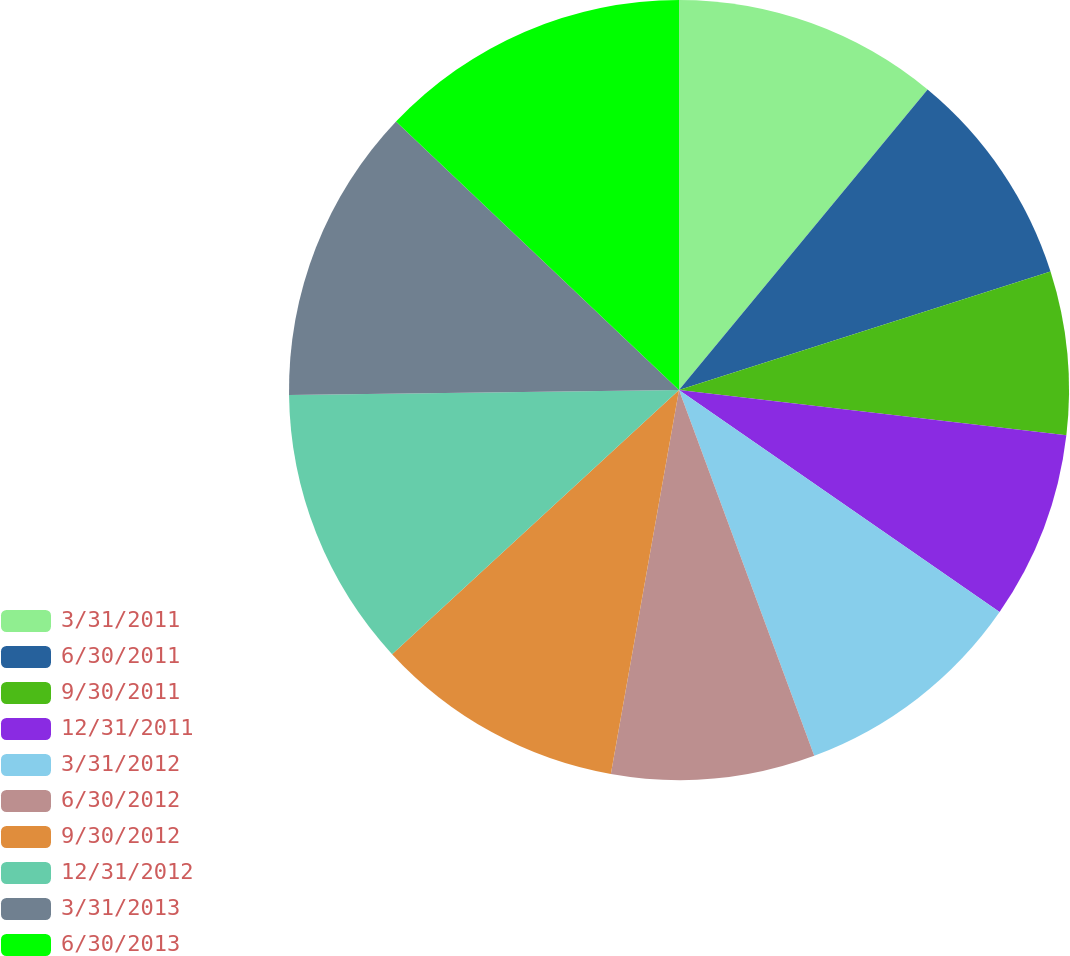Convert chart to OTSL. <chart><loc_0><loc_0><loc_500><loc_500><pie_chart><fcel>3/31/2011<fcel>6/30/2011<fcel>9/30/2011<fcel>12/31/2011<fcel>3/31/2012<fcel>6/30/2012<fcel>9/30/2012<fcel>12/31/2012<fcel>3/31/2013<fcel>6/30/2013<nl><fcel>11.0%<fcel>9.08%<fcel>6.77%<fcel>7.79%<fcel>9.72%<fcel>8.43%<fcel>10.36%<fcel>11.64%<fcel>12.28%<fcel>12.92%<nl></chart> 